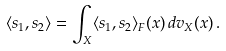<formula> <loc_0><loc_0><loc_500><loc_500>\langle s _ { 1 } , s _ { 2 } \rangle = \int _ { X } \langle s _ { 1 } , s _ { 2 } \rangle _ { F } ( x ) \, d v _ { X } ( x ) \, .</formula> 